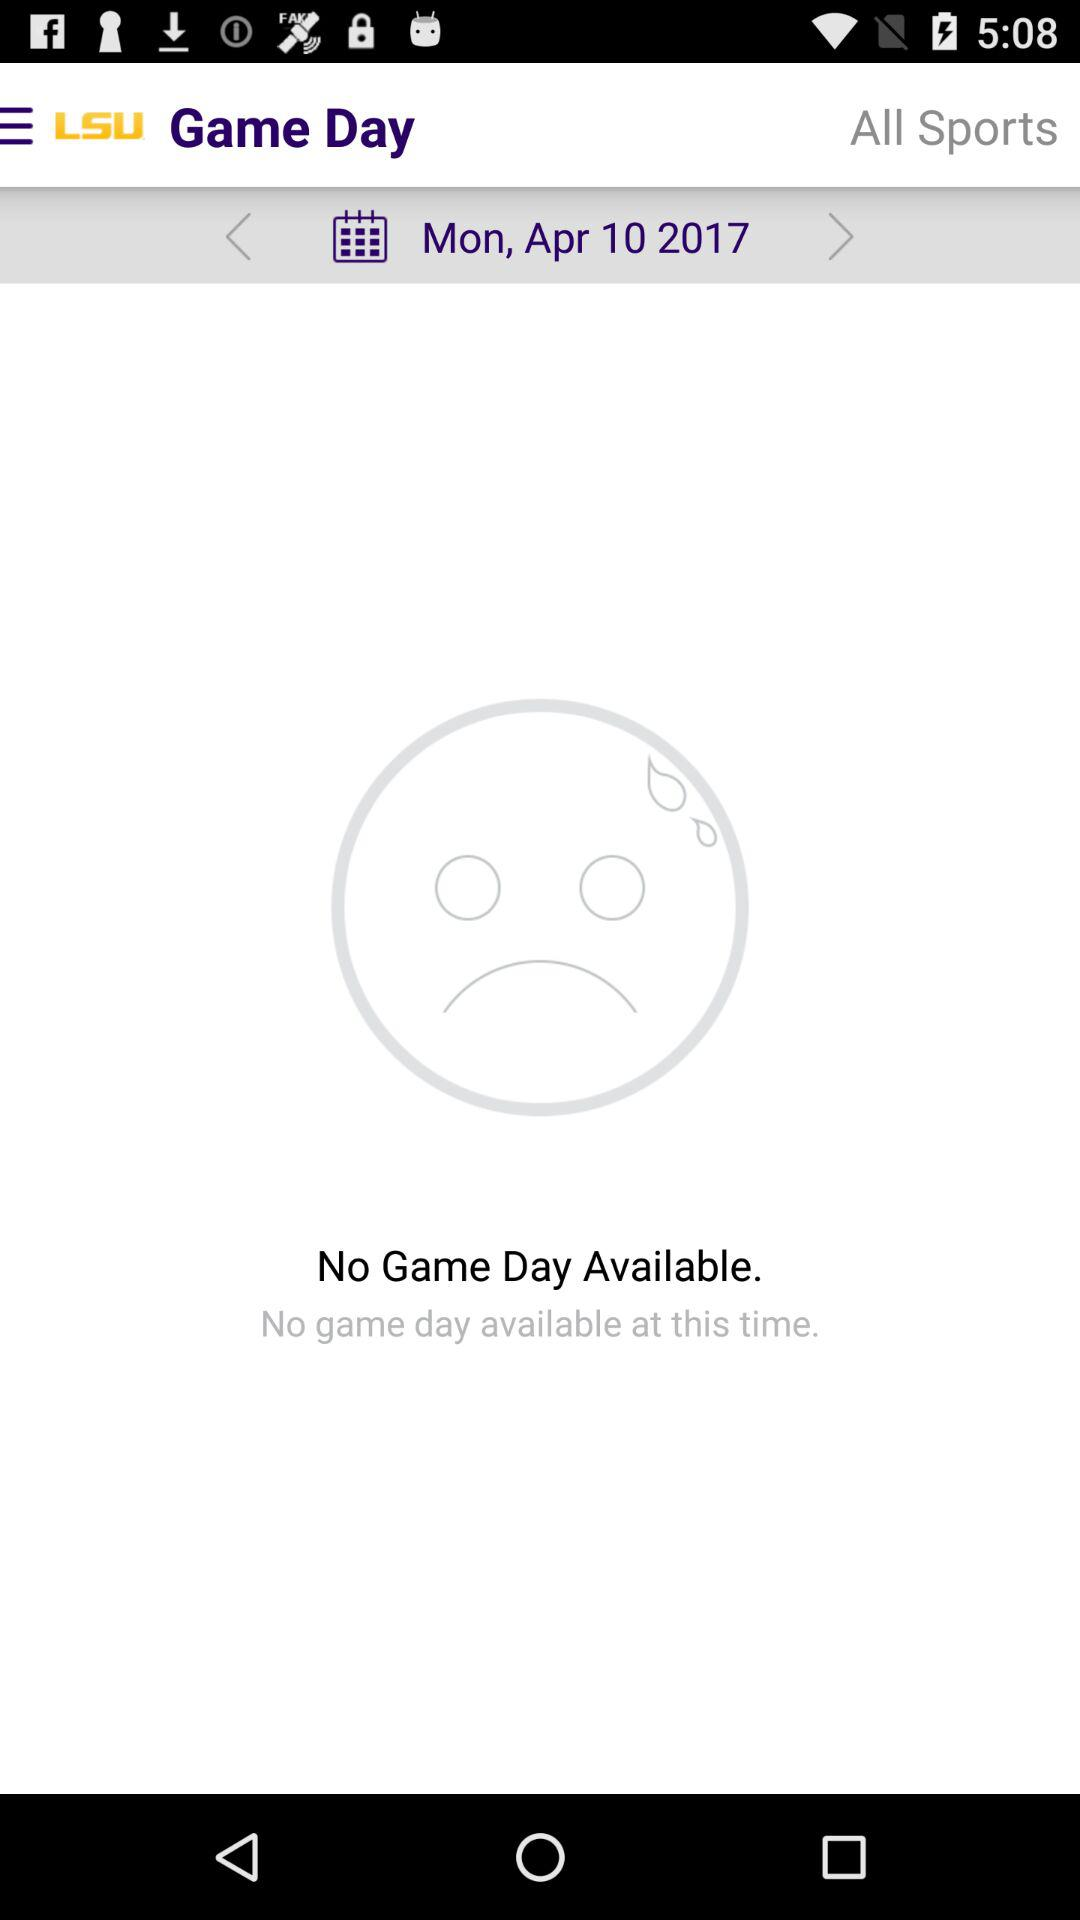What is the application name? The application name is "LSU". 